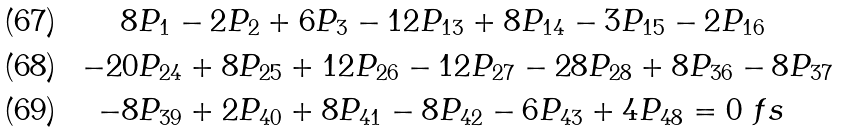<formula> <loc_0><loc_0><loc_500><loc_500>8 & P _ { 1 } - 2 P _ { 2 } + 6 P _ { 3 } - 1 2 P _ { 1 3 } + 8 P _ { 1 4 } - 3 P _ { 1 5 } - 2 P _ { 1 6 } \\ - 2 0 & P _ { 2 4 } + 8 P _ { 2 5 } + 1 2 P _ { 2 6 } - 1 2 P _ { 2 7 } - 2 8 P _ { 2 8 } + 8 P _ { 3 6 } - 8 P _ { 3 7 } \\ - 8 & P _ { 3 9 } + 2 P _ { 4 0 } + 8 P _ { 4 1 } - 8 P _ { 4 2 } - 6 P _ { 4 3 } + 4 P _ { 4 8 } = 0 \ f s</formula> 